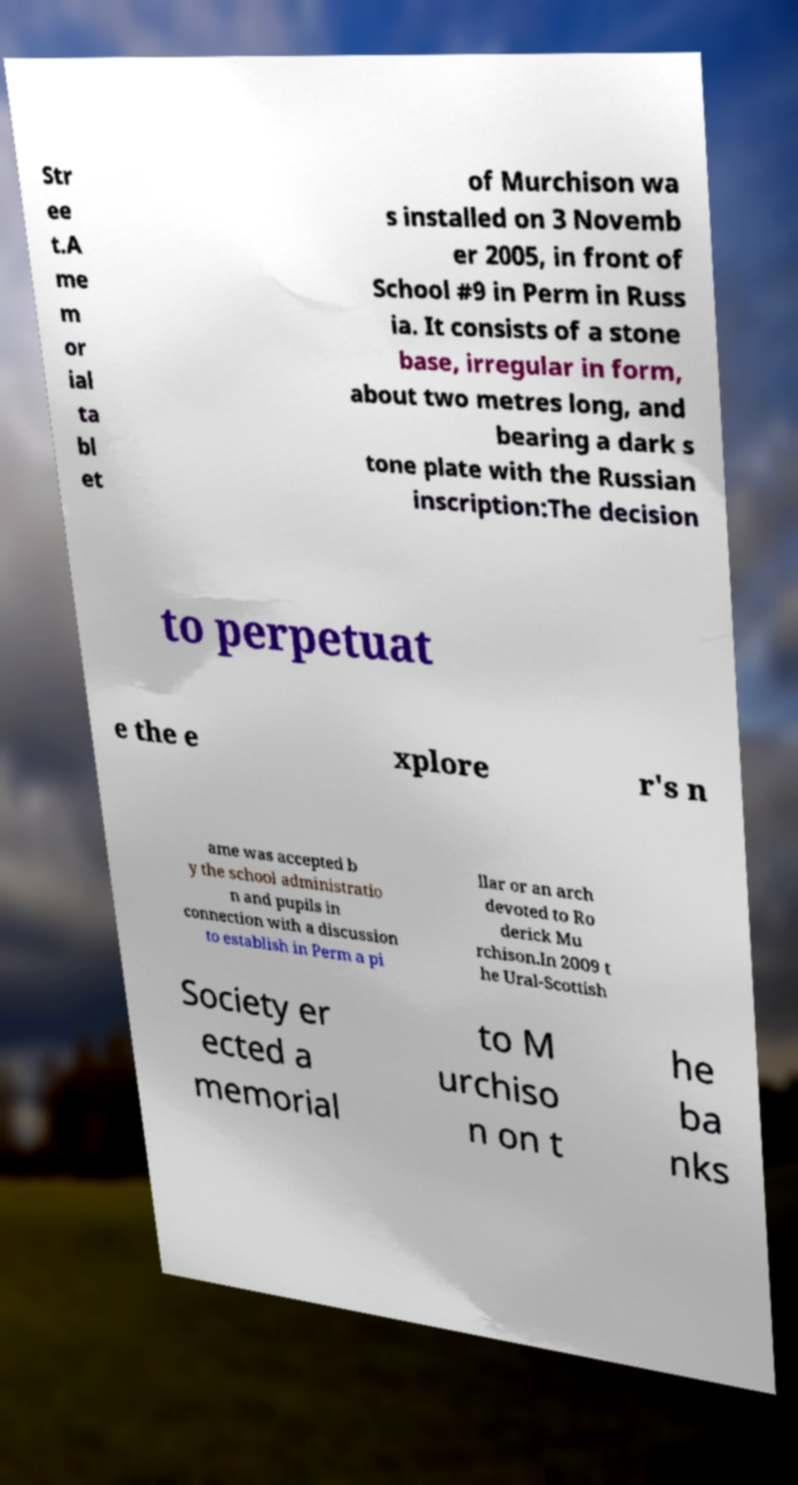Can you accurately transcribe the text from the provided image for me? Str ee t.A me m or ial ta bl et of Murchison wa s installed on 3 Novemb er 2005, in front of School #9 in Perm in Russ ia. It consists of a stone base, irregular in form, about two metres long, and bearing a dark s tone plate with the Russian inscription:The decision to perpetuat e the e xplore r's n ame was accepted b y the school administratio n and pupils in connection with a discussion to establish in Perm a pi llar or an arch devoted to Ro derick Mu rchison.In 2009 t he Ural-Scottish Society er ected a memorial to M urchiso n on t he ba nks 